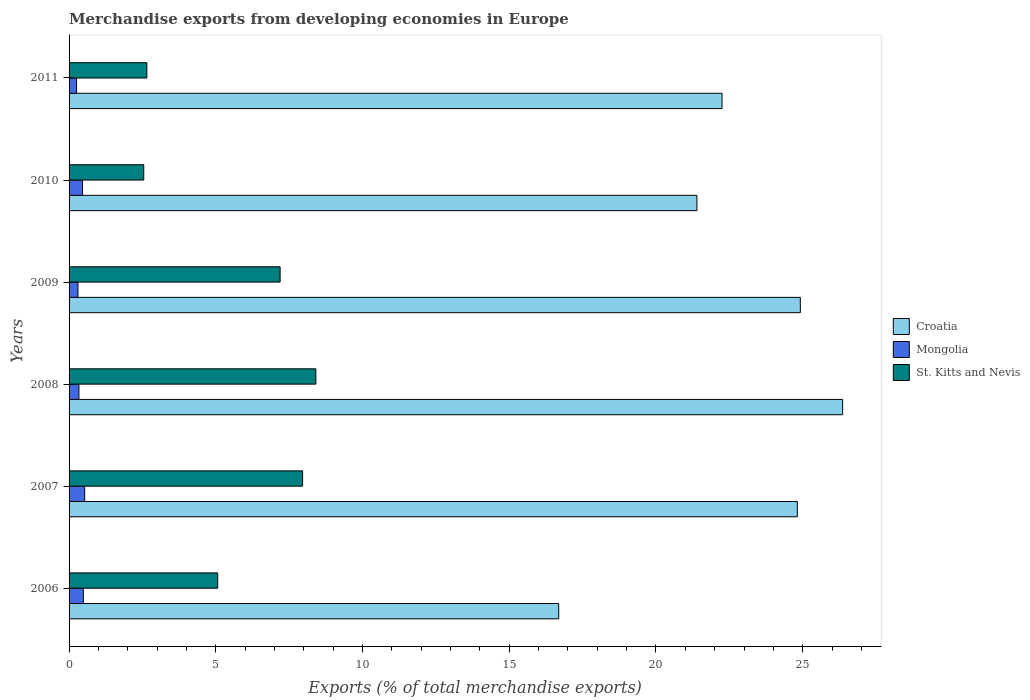How many different coloured bars are there?
Offer a very short reply. 3. How many bars are there on the 3rd tick from the top?
Offer a very short reply. 3. In how many cases, is the number of bars for a given year not equal to the number of legend labels?
Provide a short and direct response. 0. What is the percentage of total merchandise exports in Croatia in 2009?
Ensure brevity in your answer.  24.92. Across all years, what is the maximum percentage of total merchandise exports in Croatia?
Provide a succinct answer. 26.36. Across all years, what is the minimum percentage of total merchandise exports in St. Kitts and Nevis?
Provide a succinct answer. 2.55. In which year was the percentage of total merchandise exports in St. Kitts and Nevis maximum?
Your answer should be compact. 2008. What is the total percentage of total merchandise exports in Croatia in the graph?
Ensure brevity in your answer.  136.43. What is the difference between the percentage of total merchandise exports in Croatia in 2008 and that in 2010?
Provide a short and direct response. 4.97. What is the difference between the percentage of total merchandise exports in Croatia in 2010 and the percentage of total merchandise exports in Mongolia in 2009?
Keep it short and to the point. 21.09. What is the average percentage of total merchandise exports in Croatia per year?
Provide a succinct answer. 22.74. In the year 2006, what is the difference between the percentage of total merchandise exports in St. Kitts and Nevis and percentage of total merchandise exports in Croatia?
Give a very brief answer. -11.62. In how many years, is the percentage of total merchandise exports in St. Kitts and Nevis greater than 26 %?
Make the answer very short. 0. What is the ratio of the percentage of total merchandise exports in St. Kitts and Nevis in 2008 to that in 2011?
Provide a succinct answer. 3.17. What is the difference between the highest and the second highest percentage of total merchandise exports in St. Kitts and Nevis?
Make the answer very short. 0.45. What is the difference between the highest and the lowest percentage of total merchandise exports in St. Kitts and Nevis?
Your response must be concise. 5.87. What does the 3rd bar from the top in 2009 represents?
Provide a short and direct response. Croatia. What does the 2nd bar from the bottom in 2007 represents?
Your answer should be very brief. Mongolia. Is it the case that in every year, the sum of the percentage of total merchandise exports in Croatia and percentage of total merchandise exports in St. Kitts and Nevis is greater than the percentage of total merchandise exports in Mongolia?
Give a very brief answer. Yes. How many years are there in the graph?
Make the answer very short. 6. Does the graph contain grids?
Ensure brevity in your answer.  No. Where does the legend appear in the graph?
Keep it short and to the point. Center right. How many legend labels are there?
Offer a terse response. 3. How are the legend labels stacked?
Your answer should be compact. Vertical. What is the title of the graph?
Keep it short and to the point. Merchandise exports from developing economies in Europe. What is the label or title of the X-axis?
Keep it short and to the point. Exports (% of total merchandise exports). What is the Exports (% of total merchandise exports) in Croatia in 2006?
Your answer should be very brief. 16.69. What is the Exports (% of total merchandise exports) of Mongolia in 2006?
Offer a terse response. 0.49. What is the Exports (% of total merchandise exports) in St. Kitts and Nevis in 2006?
Provide a short and direct response. 5.06. What is the Exports (% of total merchandise exports) of Croatia in 2007?
Ensure brevity in your answer.  24.82. What is the Exports (% of total merchandise exports) in Mongolia in 2007?
Your response must be concise. 0.53. What is the Exports (% of total merchandise exports) in St. Kitts and Nevis in 2007?
Offer a very short reply. 7.96. What is the Exports (% of total merchandise exports) of Croatia in 2008?
Your response must be concise. 26.36. What is the Exports (% of total merchandise exports) in Mongolia in 2008?
Provide a succinct answer. 0.33. What is the Exports (% of total merchandise exports) in St. Kitts and Nevis in 2008?
Offer a very short reply. 8.41. What is the Exports (% of total merchandise exports) of Croatia in 2009?
Your answer should be very brief. 24.92. What is the Exports (% of total merchandise exports) of Mongolia in 2009?
Provide a succinct answer. 0.3. What is the Exports (% of total merchandise exports) of St. Kitts and Nevis in 2009?
Offer a terse response. 7.19. What is the Exports (% of total merchandise exports) in Croatia in 2010?
Ensure brevity in your answer.  21.4. What is the Exports (% of total merchandise exports) in Mongolia in 2010?
Offer a very short reply. 0.46. What is the Exports (% of total merchandise exports) of St. Kitts and Nevis in 2010?
Your response must be concise. 2.55. What is the Exports (% of total merchandise exports) of Croatia in 2011?
Your answer should be very brief. 22.25. What is the Exports (% of total merchandise exports) of Mongolia in 2011?
Make the answer very short. 0.26. What is the Exports (% of total merchandise exports) of St. Kitts and Nevis in 2011?
Provide a short and direct response. 2.65. Across all years, what is the maximum Exports (% of total merchandise exports) in Croatia?
Ensure brevity in your answer.  26.36. Across all years, what is the maximum Exports (% of total merchandise exports) in Mongolia?
Provide a short and direct response. 0.53. Across all years, what is the maximum Exports (% of total merchandise exports) of St. Kitts and Nevis?
Your response must be concise. 8.41. Across all years, what is the minimum Exports (% of total merchandise exports) in Croatia?
Offer a very short reply. 16.69. Across all years, what is the minimum Exports (% of total merchandise exports) in Mongolia?
Make the answer very short. 0.26. Across all years, what is the minimum Exports (% of total merchandise exports) in St. Kitts and Nevis?
Make the answer very short. 2.55. What is the total Exports (% of total merchandise exports) in Croatia in the graph?
Offer a terse response. 136.43. What is the total Exports (% of total merchandise exports) in Mongolia in the graph?
Your answer should be very brief. 2.37. What is the total Exports (% of total merchandise exports) of St. Kitts and Nevis in the graph?
Your answer should be very brief. 33.82. What is the difference between the Exports (% of total merchandise exports) in Croatia in 2006 and that in 2007?
Provide a succinct answer. -8.13. What is the difference between the Exports (% of total merchandise exports) in Mongolia in 2006 and that in 2007?
Give a very brief answer. -0.05. What is the difference between the Exports (% of total merchandise exports) in St. Kitts and Nevis in 2006 and that in 2007?
Give a very brief answer. -2.89. What is the difference between the Exports (% of total merchandise exports) of Croatia in 2006 and that in 2008?
Keep it short and to the point. -9.67. What is the difference between the Exports (% of total merchandise exports) of Mongolia in 2006 and that in 2008?
Make the answer very short. 0.15. What is the difference between the Exports (% of total merchandise exports) of St. Kitts and Nevis in 2006 and that in 2008?
Provide a succinct answer. -3.35. What is the difference between the Exports (% of total merchandise exports) of Croatia in 2006 and that in 2009?
Ensure brevity in your answer.  -8.23. What is the difference between the Exports (% of total merchandise exports) in Mongolia in 2006 and that in 2009?
Your answer should be very brief. 0.18. What is the difference between the Exports (% of total merchandise exports) of St. Kitts and Nevis in 2006 and that in 2009?
Your response must be concise. -2.13. What is the difference between the Exports (% of total merchandise exports) of Croatia in 2006 and that in 2010?
Offer a terse response. -4.71. What is the difference between the Exports (% of total merchandise exports) of Mongolia in 2006 and that in 2010?
Provide a succinct answer. 0.03. What is the difference between the Exports (% of total merchandise exports) in St. Kitts and Nevis in 2006 and that in 2010?
Give a very brief answer. 2.52. What is the difference between the Exports (% of total merchandise exports) of Croatia in 2006 and that in 2011?
Provide a succinct answer. -5.57. What is the difference between the Exports (% of total merchandise exports) of Mongolia in 2006 and that in 2011?
Ensure brevity in your answer.  0.23. What is the difference between the Exports (% of total merchandise exports) in St. Kitts and Nevis in 2006 and that in 2011?
Provide a short and direct response. 2.41. What is the difference between the Exports (% of total merchandise exports) in Croatia in 2007 and that in 2008?
Ensure brevity in your answer.  -1.54. What is the difference between the Exports (% of total merchandise exports) of Mongolia in 2007 and that in 2008?
Your response must be concise. 0.2. What is the difference between the Exports (% of total merchandise exports) of St. Kitts and Nevis in 2007 and that in 2008?
Provide a succinct answer. -0.45. What is the difference between the Exports (% of total merchandise exports) of Croatia in 2007 and that in 2009?
Give a very brief answer. -0.1. What is the difference between the Exports (% of total merchandise exports) in Mongolia in 2007 and that in 2009?
Make the answer very short. 0.23. What is the difference between the Exports (% of total merchandise exports) in St. Kitts and Nevis in 2007 and that in 2009?
Provide a short and direct response. 0.77. What is the difference between the Exports (% of total merchandise exports) in Croatia in 2007 and that in 2010?
Keep it short and to the point. 3.42. What is the difference between the Exports (% of total merchandise exports) of Mongolia in 2007 and that in 2010?
Provide a short and direct response. 0.07. What is the difference between the Exports (% of total merchandise exports) in St. Kitts and Nevis in 2007 and that in 2010?
Provide a short and direct response. 5.41. What is the difference between the Exports (% of total merchandise exports) of Croatia in 2007 and that in 2011?
Ensure brevity in your answer.  2.56. What is the difference between the Exports (% of total merchandise exports) of Mongolia in 2007 and that in 2011?
Your answer should be compact. 0.28. What is the difference between the Exports (% of total merchandise exports) of St. Kitts and Nevis in 2007 and that in 2011?
Make the answer very short. 5.31. What is the difference between the Exports (% of total merchandise exports) of Croatia in 2008 and that in 2009?
Keep it short and to the point. 1.44. What is the difference between the Exports (% of total merchandise exports) of Mongolia in 2008 and that in 2009?
Your answer should be compact. 0.03. What is the difference between the Exports (% of total merchandise exports) in St. Kitts and Nevis in 2008 and that in 2009?
Provide a short and direct response. 1.22. What is the difference between the Exports (% of total merchandise exports) of Croatia in 2008 and that in 2010?
Ensure brevity in your answer.  4.97. What is the difference between the Exports (% of total merchandise exports) in Mongolia in 2008 and that in 2010?
Provide a succinct answer. -0.12. What is the difference between the Exports (% of total merchandise exports) of St. Kitts and Nevis in 2008 and that in 2010?
Your answer should be compact. 5.87. What is the difference between the Exports (% of total merchandise exports) of Croatia in 2008 and that in 2011?
Give a very brief answer. 4.11. What is the difference between the Exports (% of total merchandise exports) of Mongolia in 2008 and that in 2011?
Provide a short and direct response. 0.08. What is the difference between the Exports (% of total merchandise exports) of St. Kitts and Nevis in 2008 and that in 2011?
Your answer should be very brief. 5.76. What is the difference between the Exports (% of total merchandise exports) of Croatia in 2009 and that in 2010?
Provide a succinct answer. 3.52. What is the difference between the Exports (% of total merchandise exports) in Mongolia in 2009 and that in 2010?
Your answer should be compact. -0.15. What is the difference between the Exports (% of total merchandise exports) in St. Kitts and Nevis in 2009 and that in 2010?
Give a very brief answer. 4.65. What is the difference between the Exports (% of total merchandise exports) of Croatia in 2009 and that in 2011?
Provide a short and direct response. 2.67. What is the difference between the Exports (% of total merchandise exports) of Mongolia in 2009 and that in 2011?
Provide a succinct answer. 0.05. What is the difference between the Exports (% of total merchandise exports) in St. Kitts and Nevis in 2009 and that in 2011?
Give a very brief answer. 4.54. What is the difference between the Exports (% of total merchandise exports) in Croatia in 2010 and that in 2011?
Keep it short and to the point. -0.86. What is the difference between the Exports (% of total merchandise exports) of Mongolia in 2010 and that in 2011?
Ensure brevity in your answer.  0.2. What is the difference between the Exports (% of total merchandise exports) of St. Kitts and Nevis in 2010 and that in 2011?
Provide a succinct answer. -0.11. What is the difference between the Exports (% of total merchandise exports) in Croatia in 2006 and the Exports (% of total merchandise exports) in Mongolia in 2007?
Keep it short and to the point. 16.16. What is the difference between the Exports (% of total merchandise exports) in Croatia in 2006 and the Exports (% of total merchandise exports) in St. Kitts and Nevis in 2007?
Make the answer very short. 8.73. What is the difference between the Exports (% of total merchandise exports) in Mongolia in 2006 and the Exports (% of total merchandise exports) in St. Kitts and Nevis in 2007?
Make the answer very short. -7.47. What is the difference between the Exports (% of total merchandise exports) of Croatia in 2006 and the Exports (% of total merchandise exports) of Mongolia in 2008?
Keep it short and to the point. 16.35. What is the difference between the Exports (% of total merchandise exports) of Croatia in 2006 and the Exports (% of total merchandise exports) of St. Kitts and Nevis in 2008?
Ensure brevity in your answer.  8.28. What is the difference between the Exports (% of total merchandise exports) in Mongolia in 2006 and the Exports (% of total merchandise exports) in St. Kitts and Nevis in 2008?
Make the answer very short. -7.92. What is the difference between the Exports (% of total merchandise exports) of Croatia in 2006 and the Exports (% of total merchandise exports) of Mongolia in 2009?
Your answer should be compact. 16.38. What is the difference between the Exports (% of total merchandise exports) of Croatia in 2006 and the Exports (% of total merchandise exports) of St. Kitts and Nevis in 2009?
Offer a terse response. 9.49. What is the difference between the Exports (% of total merchandise exports) in Mongolia in 2006 and the Exports (% of total merchandise exports) in St. Kitts and Nevis in 2009?
Provide a succinct answer. -6.71. What is the difference between the Exports (% of total merchandise exports) of Croatia in 2006 and the Exports (% of total merchandise exports) of Mongolia in 2010?
Keep it short and to the point. 16.23. What is the difference between the Exports (% of total merchandise exports) in Croatia in 2006 and the Exports (% of total merchandise exports) in St. Kitts and Nevis in 2010?
Your answer should be very brief. 14.14. What is the difference between the Exports (% of total merchandise exports) in Mongolia in 2006 and the Exports (% of total merchandise exports) in St. Kitts and Nevis in 2010?
Your answer should be compact. -2.06. What is the difference between the Exports (% of total merchandise exports) in Croatia in 2006 and the Exports (% of total merchandise exports) in Mongolia in 2011?
Your answer should be very brief. 16.43. What is the difference between the Exports (% of total merchandise exports) in Croatia in 2006 and the Exports (% of total merchandise exports) in St. Kitts and Nevis in 2011?
Your response must be concise. 14.04. What is the difference between the Exports (% of total merchandise exports) in Mongolia in 2006 and the Exports (% of total merchandise exports) in St. Kitts and Nevis in 2011?
Provide a succinct answer. -2.17. What is the difference between the Exports (% of total merchandise exports) of Croatia in 2007 and the Exports (% of total merchandise exports) of Mongolia in 2008?
Give a very brief answer. 24.48. What is the difference between the Exports (% of total merchandise exports) of Croatia in 2007 and the Exports (% of total merchandise exports) of St. Kitts and Nevis in 2008?
Your answer should be compact. 16.41. What is the difference between the Exports (% of total merchandise exports) of Mongolia in 2007 and the Exports (% of total merchandise exports) of St. Kitts and Nevis in 2008?
Offer a terse response. -7.88. What is the difference between the Exports (% of total merchandise exports) of Croatia in 2007 and the Exports (% of total merchandise exports) of Mongolia in 2009?
Your answer should be very brief. 24.51. What is the difference between the Exports (% of total merchandise exports) of Croatia in 2007 and the Exports (% of total merchandise exports) of St. Kitts and Nevis in 2009?
Provide a succinct answer. 17.62. What is the difference between the Exports (% of total merchandise exports) in Mongolia in 2007 and the Exports (% of total merchandise exports) in St. Kitts and Nevis in 2009?
Give a very brief answer. -6.66. What is the difference between the Exports (% of total merchandise exports) in Croatia in 2007 and the Exports (% of total merchandise exports) in Mongolia in 2010?
Offer a very short reply. 24.36. What is the difference between the Exports (% of total merchandise exports) of Croatia in 2007 and the Exports (% of total merchandise exports) of St. Kitts and Nevis in 2010?
Your answer should be very brief. 22.27. What is the difference between the Exports (% of total merchandise exports) of Mongolia in 2007 and the Exports (% of total merchandise exports) of St. Kitts and Nevis in 2010?
Your answer should be very brief. -2.01. What is the difference between the Exports (% of total merchandise exports) of Croatia in 2007 and the Exports (% of total merchandise exports) of Mongolia in 2011?
Make the answer very short. 24.56. What is the difference between the Exports (% of total merchandise exports) of Croatia in 2007 and the Exports (% of total merchandise exports) of St. Kitts and Nevis in 2011?
Keep it short and to the point. 22.17. What is the difference between the Exports (% of total merchandise exports) of Mongolia in 2007 and the Exports (% of total merchandise exports) of St. Kitts and Nevis in 2011?
Provide a succinct answer. -2.12. What is the difference between the Exports (% of total merchandise exports) of Croatia in 2008 and the Exports (% of total merchandise exports) of Mongolia in 2009?
Offer a terse response. 26.06. What is the difference between the Exports (% of total merchandise exports) of Croatia in 2008 and the Exports (% of total merchandise exports) of St. Kitts and Nevis in 2009?
Keep it short and to the point. 19.17. What is the difference between the Exports (% of total merchandise exports) of Mongolia in 2008 and the Exports (% of total merchandise exports) of St. Kitts and Nevis in 2009?
Offer a very short reply. -6.86. What is the difference between the Exports (% of total merchandise exports) in Croatia in 2008 and the Exports (% of total merchandise exports) in Mongolia in 2010?
Provide a succinct answer. 25.9. What is the difference between the Exports (% of total merchandise exports) of Croatia in 2008 and the Exports (% of total merchandise exports) of St. Kitts and Nevis in 2010?
Make the answer very short. 23.82. What is the difference between the Exports (% of total merchandise exports) in Mongolia in 2008 and the Exports (% of total merchandise exports) in St. Kitts and Nevis in 2010?
Your answer should be very brief. -2.21. What is the difference between the Exports (% of total merchandise exports) in Croatia in 2008 and the Exports (% of total merchandise exports) in Mongolia in 2011?
Make the answer very short. 26.11. What is the difference between the Exports (% of total merchandise exports) of Croatia in 2008 and the Exports (% of total merchandise exports) of St. Kitts and Nevis in 2011?
Offer a very short reply. 23.71. What is the difference between the Exports (% of total merchandise exports) of Mongolia in 2008 and the Exports (% of total merchandise exports) of St. Kitts and Nevis in 2011?
Offer a very short reply. -2.32. What is the difference between the Exports (% of total merchandise exports) of Croatia in 2009 and the Exports (% of total merchandise exports) of Mongolia in 2010?
Ensure brevity in your answer.  24.46. What is the difference between the Exports (% of total merchandise exports) of Croatia in 2009 and the Exports (% of total merchandise exports) of St. Kitts and Nevis in 2010?
Give a very brief answer. 22.37. What is the difference between the Exports (% of total merchandise exports) in Mongolia in 2009 and the Exports (% of total merchandise exports) in St. Kitts and Nevis in 2010?
Your response must be concise. -2.24. What is the difference between the Exports (% of total merchandise exports) of Croatia in 2009 and the Exports (% of total merchandise exports) of Mongolia in 2011?
Keep it short and to the point. 24.66. What is the difference between the Exports (% of total merchandise exports) in Croatia in 2009 and the Exports (% of total merchandise exports) in St. Kitts and Nevis in 2011?
Make the answer very short. 22.27. What is the difference between the Exports (% of total merchandise exports) of Mongolia in 2009 and the Exports (% of total merchandise exports) of St. Kitts and Nevis in 2011?
Provide a short and direct response. -2.35. What is the difference between the Exports (% of total merchandise exports) in Croatia in 2010 and the Exports (% of total merchandise exports) in Mongolia in 2011?
Keep it short and to the point. 21.14. What is the difference between the Exports (% of total merchandise exports) of Croatia in 2010 and the Exports (% of total merchandise exports) of St. Kitts and Nevis in 2011?
Make the answer very short. 18.74. What is the difference between the Exports (% of total merchandise exports) in Mongolia in 2010 and the Exports (% of total merchandise exports) in St. Kitts and Nevis in 2011?
Ensure brevity in your answer.  -2.19. What is the average Exports (% of total merchandise exports) in Croatia per year?
Make the answer very short. 22.74. What is the average Exports (% of total merchandise exports) of Mongolia per year?
Make the answer very short. 0.39. What is the average Exports (% of total merchandise exports) of St. Kitts and Nevis per year?
Give a very brief answer. 5.64. In the year 2006, what is the difference between the Exports (% of total merchandise exports) of Croatia and Exports (% of total merchandise exports) of Mongolia?
Make the answer very short. 16.2. In the year 2006, what is the difference between the Exports (% of total merchandise exports) in Croatia and Exports (% of total merchandise exports) in St. Kitts and Nevis?
Provide a short and direct response. 11.62. In the year 2006, what is the difference between the Exports (% of total merchandise exports) of Mongolia and Exports (% of total merchandise exports) of St. Kitts and Nevis?
Keep it short and to the point. -4.58. In the year 2007, what is the difference between the Exports (% of total merchandise exports) of Croatia and Exports (% of total merchandise exports) of Mongolia?
Give a very brief answer. 24.29. In the year 2007, what is the difference between the Exports (% of total merchandise exports) in Croatia and Exports (% of total merchandise exports) in St. Kitts and Nevis?
Offer a very short reply. 16.86. In the year 2007, what is the difference between the Exports (% of total merchandise exports) of Mongolia and Exports (% of total merchandise exports) of St. Kitts and Nevis?
Offer a very short reply. -7.43. In the year 2008, what is the difference between the Exports (% of total merchandise exports) in Croatia and Exports (% of total merchandise exports) in Mongolia?
Offer a terse response. 26.03. In the year 2008, what is the difference between the Exports (% of total merchandise exports) of Croatia and Exports (% of total merchandise exports) of St. Kitts and Nevis?
Your answer should be compact. 17.95. In the year 2008, what is the difference between the Exports (% of total merchandise exports) of Mongolia and Exports (% of total merchandise exports) of St. Kitts and Nevis?
Provide a short and direct response. -8.08. In the year 2009, what is the difference between the Exports (% of total merchandise exports) of Croatia and Exports (% of total merchandise exports) of Mongolia?
Keep it short and to the point. 24.62. In the year 2009, what is the difference between the Exports (% of total merchandise exports) in Croatia and Exports (% of total merchandise exports) in St. Kitts and Nevis?
Provide a short and direct response. 17.73. In the year 2009, what is the difference between the Exports (% of total merchandise exports) in Mongolia and Exports (% of total merchandise exports) in St. Kitts and Nevis?
Your response must be concise. -6.89. In the year 2010, what is the difference between the Exports (% of total merchandise exports) of Croatia and Exports (% of total merchandise exports) of Mongolia?
Your answer should be compact. 20.94. In the year 2010, what is the difference between the Exports (% of total merchandise exports) in Croatia and Exports (% of total merchandise exports) in St. Kitts and Nevis?
Ensure brevity in your answer.  18.85. In the year 2010, what is the difference between the Exports (% of total merchandise exports) of Mongolia and Exports (% of total merchandise exports) of St. Kitts and Nevis?
Offer a terse response. -2.09. In the year 2011, what is the difference between the Exports (% of total merchandise exports) of Croatia and Exports (% of total merchandise exports) of Mongolia?
Your answer should be very brief. 22. In the year 2011, what is the difference between the Exports (% of total merchandise exports) in Croatia and Exports (% of total merchandise exports) in St. Kitts and Nevis?
Provide a short and direct response. 19.6. In the year 2011, what is the difference between the Exports (% of total merchandise exports) in Mongolia and Exports (% of total merchandise exports) in St. Kitts and Nevis?
Your answer should be compact. -2.4. What is the ratio of the Exports (% of total merchandise exports) of Croatia in 2006 to that in 2007?
Offer a terse response. 0.67. What is the ratio of the Exports (% of total merchandise exports) of Mongolia in 2006 to that in 2007?
Provide a short and direct response. 0.91. What is the ratio of the Exports (% of total merchandise exports) in St. Kitts and Nevis in 2006 to that in 2007?
Your answer should be very brief. 0.64. What is the ratio of the Exports (% of total merchandise exports) in Croatia in 2006 to that in 2008?
Ensure brevity in your answer.  0.63. What is the ratio of the Exports (% of total merchandise exports) in Mongolia in 2006 to that in 2008?
Your response must be concise. 1.45. What is the ratio of the Exports (% of total merchandise exports) of St. Kitts and Nevis in 2006 to that in 2008?
Make the answer very short. 0.6. What is the ratio of the Exports (% of total merchandise exports) of Croatia in 2006 to that in 2009?
Provide a short and direct response. 0.67. What is the ratio of the Exports (% of total merchandise exports) of Mongolia in 2006 to that in 2009?
Ensure brevity in your answer.  1.6. What is the ratio of the Exports (% of total merchandise exports) in St. Kitts and Nevis in 2006 to that in 2009?
Your response must be concise. 0.7. What is the ratio of the Exports (% of total merchandise exports) in Croatia in 2006 to that in 2010?
Provide a succinct answer. 0.78. What is the ratio of the Exports (% of total merchandise exports) of Mongolia in 2006 to that in 2010?
Give a very brief answer. 1.06. What is the ratio of the Exports (% of total merchandise exports) of St. Kitts and Nevis in 2006 to that in 2010?
Provide a succinct answer. 1.99. What is the ratio of the Exports (% of total merchandise exports) in Croatia in 2006 to that in 2011?
Offer a very short reply. 0.75. What is the ratio of the Exports (% of total merchandise exports) of Mongolia in 2006 to that in 2011?
Make the answer very short. 1.9. What is the ratio of the Exports (% of total merchandise exports) of St. Kitts and Nevis in 2006 to that in 2011?
Keep it short and to the point. 1.91. What is the ratio of the Exports (% of total merchandise exports) of Croatia in 2007 to that in 2008?
Offer a terse response. 0.94. What is the ratio of the Exports (% of total merchandise exports) of Mongolia in 2007 to that in 2008?
Give a very brief answer. 1.59. What is the ratio of the Exports (% of total merchandise exports) of St. Kitts and Nevis in 2007 to that in 2008?
Ensure brevity in your answer.  0.95. What is the ratio of the Exports (% of total merchandise exports) of Croatia in 2007 to that in 2009?
Provide a short and direct response. 1. What is the ratio of the Exports (% of total merchandise exports) of Mongolia in 2007 to that in 2009?
Offer a very short reply. 1.75. What is the ratio of the Exports (% of total merchandise exports) of St. Kitts and Nevis in 2007 to that in 2009?
Your answer should be very brief. 1.11. What is the ratio of the Exports (% of total merchandise exports) in Croatia in 2007 to that in 2010?
Your answer should be compact. 1.16. What is the ratio of the Exports (% of total merchandise exports) of Mongolia in 2007 to that in 2010?
Provide a succinct answer. 1.16. What is the ratio of the Exports (% of total merchandise exports) in St. Kitts and Nevis in 2007 to that in 2010?
Keep it short and to the point. 3.13. What is the ratio of the Exports (% of total merchandise exports) in Croatia in 2007 to that in 2011?
Offer a terse response. 1.12. What is the ratio of the Exports (% of total merchandise exports) in Mongolia in 2007 to that in 2011?
Make the answer very short. 2.08. What is the ratio of the Exports (% of total merchandise exports) of St. Kitts and Nevis in 2007 to that in 2011?
Your answer should be compact. 3. What is the ratio of the Exports (% of total merchandise exports) of Croatia in 2008 to that in 2009?
Ensure brevity in your answer.  1.06. What is the ratio of the Exports (% of total merchandise exports) in Mongolia in 2008 to that in 2009?
Ensure brevity in your answer.  1.1. What is the ratio of the Exports (% of total merchandise exports) of St. Kitts and Nevis in 2008 to that in 2009?
Provide a succinct answer. 1.17. What is the ratio of the Exports (% of total merchandise exports) of Croatia in 2008 to that in 2010?
Your answer should be very brief. 1.23. What is the ratio of the Exports (% of total merchandise exports) in Mongolia in 2008 to that in 2010?
Give a very brief answer. 0.73. What is the ratio of the Exports (% of total merchandise exports) in St. Kitts and Nevis in 2008 to that in 2010?
Give a very brief answer. 3.3. What is the ratio of the Exports (% of total merchandise exports) of Croatia in 2008 to that in 2011?
Make the answer very short. 1.18. What is the ratio of the Exports (% of total merchandise exports) of Mongolia in 2008 to that in 2011?
Keep it short and to the point. 1.31. What is the ratio of the Exports (% of total merchandise exports) of St. Kitts and Nevis in 2008 to that in 2011?
Make the answer very short. 3.17. What is the ratio of the Exports (% of total merchandise exports) in Croatia in 2009 to that in 2010?
Provide a short and direct response. 1.16. What is the ratio of the Exports (% of total merchandise exports) in Mongolia in 2009 to that in 2010?
Keep it short and to the point. 0.66. What is the ratio of the Exports (% of total merchandise exports) in St. Kitts and Nevis in 2009 to that in 2010?
Make the answer very short. 2.83. What is the ratio of the Exports (% of total merchandise exports) of Croatia in 2009 to that in 2011?
Ensure brevity in your answer.  1.12. What is the ratio of the Exports (% of total merchandise exports) of Mongolia in 2009 to that in 2011?
Make the answer very short. 1.19. What is the ratio of the Exports (% of total merchandise exports) of St. Kitts and Nevis in 2009 to that in 2011?
Provide a succinct answer. 2.71. What is the ratio of the Exports (% of total merchandise exports) of Croatia in 2010 to that in 2011?
Your response must be concise. 0.96. What is the ratio of the Exports (% of total merchandise exports) of Mongolia in 2010 to that in 2011?
Your answer should be very brief. 1.79. What is the ratio of the Exports (% of total merchandise exports) in St. Kitts and Nevis in 2010 to that in 2011?
Make the answer very short. 0.96. What is the difference between the highest and the second highest Exports (% of total merchandise exports) in Croatia?
Your answer should be very brief. 1.44. What is the difference between the highest and the second highest Exports (% of total merchandise exports) in Mongolia?
Keep it short and to the point. 0.05. What is the difference between the highest and the second highest Exports (% of total merchandise exports) of St. Kitts and Nevis?
Your answer should be very brief. 0.45. What is the difference between the highest and the lowest Exports (% of total merchandise exports) of Croatia?
Your response must be concise. 9.67. What is the difference between the highest and the lowest Exports (% of total merchandise exports) of Mongolia?
Keep it short and to the point. 0.28. What is the difference between the highest and the lowest Exports (% of total merchandise exports) of St. Kitts and Nevis?
Your response must be concise. 5.87. 